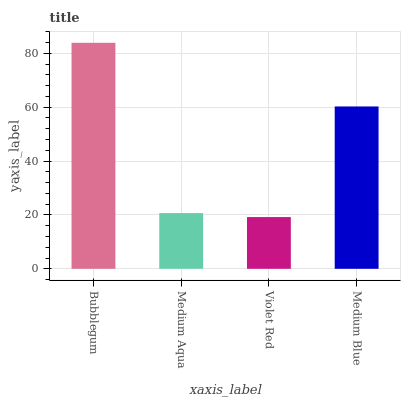Is Violet Red the minimum?
Answer yes or no. Yes. Is Bubblegum the maximum?
Answer yes or no. Yes. Is Medium Aqua the minimum?
Answer yes or no. No. Is Medium Aqua the maximum?
Answer yes or no. No. Is Bubblegum greater than Medium Aqua?
Answer yes or no. Yes. Is Medium Aqua less than Bubblegum?
Answer yes or no. Yes. Is Medium Aqua greater than Bubblegum?
Answer yes or no. No. Is Bubblegum less than Medium Aqua?
Answer yes or no. No. Is Medium Blue the high median?
Answer yes or no. Yes. Is Medium Aqua the low median?
Answer yes or no. Yes. Is Violet Red the high median?
Answer yes or no. No. Is Medium Blue the low median?
Answer yes or no. No. 